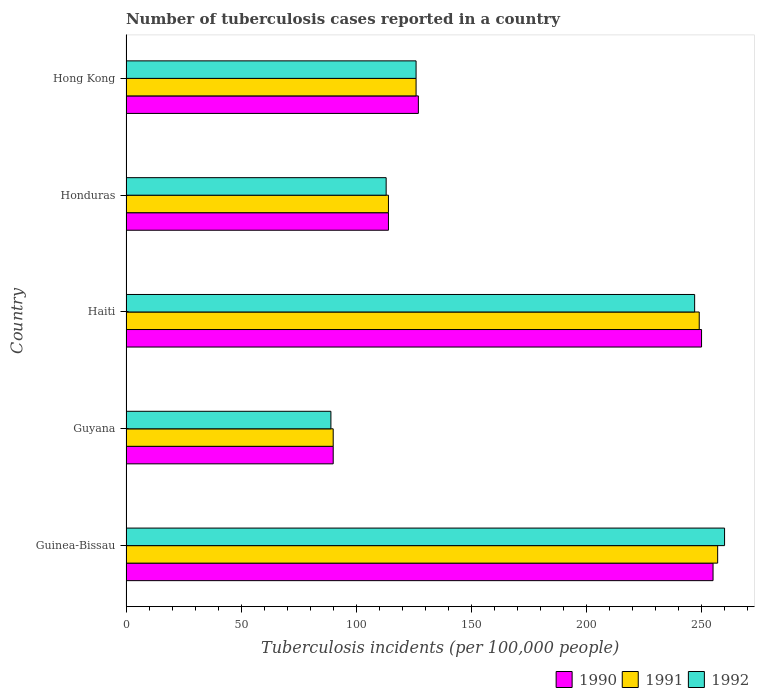How many bars are there on the 3rd tick from the top?
Give a very brief answer. 3. What is the label of the 5th group of bars from the top?
Offer a very short reply. Guinea-Bissau. Across all countries, what is the maximum number of tuberculosis cases reported in in 1992?
Give a very brief answer. 260. Across all countries, what is the minimum number of tuberculosis cases reported in in 1990?
Keep it short and to the point. 90. In which country was the number of tuberculosis cases reported in in 1991 maximum?
Keep it short and to the point. Guinea-Bissau. In which country was the number of tuberculosis cases reported in in 1992 minimum?
Offer a terse response. Guyana. What is the total number of tuberculosis cases reported in in 1991 in the graph?
Provide a short and direct response. 836. What is the difference between the number of tuberculosis cases reported in in 1992 in Guyana and that in Haiti?
Ensure brevity in your answer.  -158. What is the difference between the number of tuberculosis cases reported in in 1990 in Guyana and the number of tuberculosis cases reported in in 1992 in Guinea-Bissau?
Ensure brevity in your answer.  -170. What is the average number of tuberculosis cases reported in in 1992 per country?
Offer a terse response. 167. What is the difference between the number of tuberculosis cases reported in in 1992 and number of tuberculosis cases reported in in 1990 in Guyana?
Your response must be concise. -1. In how many countries, is the number of tuberculosis cases reported in in 1990 greater than 20 ?
Your response must be concise. 5. What is the ratio of the number of tuberculosis cases reported in in 1992 in Guinea-Bissau to that in Haiti?
Offer a very short reply. 1.05. Is the number of tuberculosis cases reported in in 1992 in Haiti less than that in Honduras?
Offer a terse response. No. What is the difference between the highest and the lowest number of tuberculosis cases reported in in 1990?
Provide a short and direct response. 165. In how many countries, is the number of tuberculosis cases reported in in 1992 greater than the average number of tuberculosis cases reported in in 1992 taken over all countries?
Your response must be concise. 2. What does the 2nd bar from the bottom in Haiti represents?
Provide a succinct answer. 1991. What is the difference between two consecutive major ticks on the X-axis?
Make the answer very short. 50. Are the values on the major ticks of X-axis written in scientific E-notation?
Provide a succinct answer. No. Does the graph contain any zero values?
Offer a terse response. No. Where does the legend appear in the graph?
Your response must be concise. Bottom right. What is the title of the graph?
Offer a very short reply. Number of tuberculosis cases reported in a country. What is the label or title of the X-axis?
Your answer should be very brief. Tuberculosis incidents (per 100,0 people). What is the label or title of the Y-axis?
Make the answer very short. Country. What is the Tuberculosis incidents (per 100,000 people) of 1990 in Guinea-Bissau?
Offer a very short reply. 255. What is the Tuberculosis incidents (per 100,000 people) of 1991 in Guinea-Bissau?
Your answer should be very brief. 257. What is the Tuberculosis incidents (per 100,000 people) in 1992 in Guinea-Bissau?
Keep it short and to the point. 260. What is the Tuberculosis incidents (per 100,000 people) in 1990 in Guyana?
Provide a succinct answer. 90. What is the Tuberculosis incidents (per 100,000 people) of 1992 in Guyana?
Your answer should be very brief. 89. What is the Tuberculosis incidents (per 100,000 people) of 1990 in Haiti?
Your answer should be very brief. 250. What is the Tuberculosis incidents (per 100,000 people) of 1991 in Haiti?
Ensure brevity in your answer.  249. What is the Tuberculosis incidents (per 100,000 people) of 1992 in Haiti?
Offer a very short reply. 247. What is the Tuberculosis incidents (per 100,000 people) of 1990 in Honduras?
Offer a very short reply. 114. What is the Tuberculosis incidents (per 100,000 people) in 1991 in Honduras?
Offer a very short reply. 114. What is the Tuberculosis incidents (per 100,000 people) in 1992 in Honduras?
Keep it short and to the point. 113. What is the Tuberculosis incidents (per 100,000 people) of 1990 in Hong Kong?
Your response must be concise. 127. What is the Tuberculosis incidents (per 100,000 people) in 1991 in Hong Kong?
Keep it short and to the point. 126. What is the Tuberculosis incidents (per 100,000 people) of 1992 in Hong Kong?
Offer a terse response. 126. Across all countries, what is the maximum Tuberculosis incidents (per 100,000 people) in 1990?
Provide a short and direct response. 255. Across all countries, what is the maximum Tuberculosis incidents (per 100,000 people) of 1991?
Offer a terse response. 257. Across all countries, what is the maximum Tuberculosis incidents (per 100,000 people) in 1992?
Provide a short and direct response. 260. Across all countries, what is the minimum Tuberculosis incidents (per 100,000 people) in 1992?
Give a very brief answer. 89. What is the total Tuberculosis incidents (per 100,000 people) in 1990 in the graph?
Ensure brevity in your answer.  836. What is the total Tuberculosis incidents (per 100,000 people) of 1991 in the graph?
Make the answer very short. 836. What is the total Tuberculosis incidents (per 100,000 people) in 1992 in the graph?
Your response must be concise. 835. What is the difference between the Tuberculosis incidents (per 100,000 people) of 1990 in Guinea-Bissau and that in Guyana?
Your answer should be very brief. 165. What is the difference between the Tuberculosis incidents (per 100,000 people) in 1991 in Guinea-Bissau and that in Guyana?
Offer a very short reply. 167. What is the difference between the Tuberculosis incidents (per 100,000 people) of 1992 in Guinea-Bissau and that in Guyana?
Ensure brevity in your answer.  171. What is the difference between the Tuberculosis incidents (per 100,000 people) in 1990 in Guinea-Bissau and that in Haiti?
Ensure brevity in your answer.  5. What is the difference between the Tuberculosis incidents (per 100,000 people) of 1992 in Guinea-Bissau and that in Haiti?
Provide a succinct answer. 13. What is the difference between the Tuberculosis incidents (per 100,000 people) of 1990 in Guinea-Bissau and that in Honduras?
Give a very brief answer. 141. What is the difference between the Tuberculosis incidents (per 100,000 people) in 1991 in Guinea-Bissau and that in Honduras?
Ensure brevity in your answer.  143. What is the difference between the Tuberculosis incidents (per 100,000 people) of 1992 in Guinea-Bissau and that in Honduras?
Your response must be concise. 147. What is the difference between the Tuberculosis incidents (per 100,000 people) of 1990 in Guinea-Bissau and that in Hong Kong?
Give a very brief answer. 128. What is the difference between the Tuberculosis incidents (per 100,000 people) of 1991 in Guinea-Bissau and that in Hong Kong?
Your answer should be very brief. 131. What is the difference between the Tuberculosis incidents (per 100,000 people) in 1992 in Guinea-Bissau and that in Hong Kong?
Keep it short and to the point. 134. What is the difference between the Tuberculosis incidents (per 100,000 people) of 1990 in Guyana and that in Haiti?
Offer a terse response. -160. What is the difference between the Tuberculosis incidents (per 100,000 people) in 1991 in Guyana and that in Haiti?
Provide a short and direct response. -159. What is the difference between the Tuberculosis incidents (per 100,000 people) in 1992 in Guyana and that in Haiti?
Provide a short and direct response. -158. What is the difference between the Tuberculosis incidents (per 100,000 people) of 1991 in Guyana and that in Honduras?
Your answer should be compact. -24. What is the difference between the Tuberculosis incidents (per 100,000 people) in 1992 in Guyana and that in Honduras?
Provide a succinct answer. -24. What is the difference between the Tuberculosis incidents (per 100,000 people) in 1990 in Guyana and that in Hong Kong?
Your answer should be compact. -37. What is the difference between the Tuberculosis incidents (per 100,000 people) of 1991 in Guyana and that in Hong Kong?
Offer a very short reply. -36. What is the difference between the Tuberculosis incidents (per 100,000 people) in 1992 in Guyana and that in Hong Kong?
Your response must be concise. -37. What is the difference between the Tuberculosis incidents (per 100,000 people) in 1990 in Haiti and that in Honduras?
Your answer should be compact. 136. What is the difference between the Tuberculosis incidents (per 100,000 people) in 1991 in Haiti and that in Honduras?
Offer a terse response. 135. What is the difference between the Tuberculosis incidents (per 100,000 people) of 1992 in Haiti and that in Honduras?
Your response must be concise. 134. What is the difference between the Tuberculosis incidents (per 100,000 people) in 1990 in Haiti and that in Hong Kong?
Provide a short and direct response. 123. What is the difference between the Tuberculosis incidents (per 100,000 people) of 1991 in Haiti and that in Hong Kong?
Your response must be concise. 123. What is the difference between the Tuberculosis incidents (per 100,000 people) of 1992 in Haiti and that in Hong Kong?
Your response must be concise. 121. What is the difference between the Tuberculosis incidents (per 100,000 people) in 1991 in Honduras and that in Hong Kong?
Provide a succinct answer. -12. What is the difference between the Tuberculosis incidents (per 100,000 people) of 1990 in Guinea-Bissau and the Tuberculosis incidents (per 100,000 people) of 1991 in Guyana?
Your response must be concise. 165. What is the difference between the Tuberculosis incidents (per 100,000 people) in 1990 in Guinea-Bissau and the Tuberculosis incidents (per 100,000 people) in 1992 in Guyana?
Offer a terse response. 166. What is the difference between the Tuberculosis incidents (per 100,000 people) in 1991 in Guinea-Bissau and the Tuberculosis incidents (per 100,000 people) in 1992 in Guyana?
Give a very brief answer. 168. What is the difference between the Tuberculosis incidents (per 100,000 people) of 1990 in Guinea-Bissau and the Tuberculosis incidents (per 100,000 people) of 1991 in Haiti?
Your answer should be compact. 6. What is the difference between the Tuberculosis incidents (per 100,000 people) of 1990 in Guinea-Bissau and the Tuberculosis incidents (per 100,000 people) of 1991 in Honduras?
Give a very brief answer. 141. What is the difference between the Tuberculosis incidents (per 100,000 people) in 1990 in Guinea-Bissau and the Tuberculosis incidents (per 100,000 people) in 1992 in Honduras?
Your response must be concise. 142. What is the difference between the Tuberculosis incidents (per 100,000 people) of 1991 in Guinea-Bissau and the Tuberculosis incidents (per 100,000 people) of 1992 in Honduras?
Your response must be concise. 144. What is the difference between the Tuberculosis incidents (per 100,000 people) in 1990 in Guinea-Bissau and the Tuberculosis incidents (per 100,000 people) in 1991 in Hong Kong?
Your answer should be compact. 129. What is the difference between the Tuberculosis incidents (per 100,000 people) in 1990 in Guinea-Bissau and the Tuberculosis incidents (per 100,000 people) in 1992 in Hong Kong?
Your response must be concise. 129. What is the difference between the Tuberculosis incidents (per 100,000 people) in 1991 in Guinea-Bissau and the Tuberculosis incidents (per 100,000 people) in 1992 in Hong Kong?
Offer a terse response. 131. What is the difference between the Tuberculosis incidents (per 100,000 people) in 1990 in Guyana and the Tuberculosis incidents (per 100,000 people) in 1991 in Haiti?
Make the answer very short. -159. What is the difference between the Tuberculosis incidents (per 100,000 people) in 1990 in Guyana and the Tuberculosis incidents (per 100,000 people) in 1992 in Haiti?
Keep it short and to the point. -157. What is the difference between the Tuberculosis incidents (per 100,000 people) in 1991 in Guyana and the Tuberculosis incidents (per 100,000 people) in 1992 in Haiti?
Offer a terse response. -157. What is the difference between the Tuberculosis incidents (per 100,000 people) of 1990 in Guyana and the Tuberculosis incidents (per 100,000 people) of 1991 in Honduras?
Your response must be concise. -24. What is the difference between the Tuberculosis incidents (per 100,000 people) of 1990 in Guyana and the Tuberculosis incidents (per 100,000 people) of 1991 in Hong Kong?
Your response must be concise. -36. What is the difference between the Tuberculosis incidents (per 100,000 people) of 1990 in Guyana and the Tuberculosis incidents (per 100,000 people) of 1992 in Hong Kong?
Make the answer very short. -36. What is the difference between the Tuberculosis incidents (per 100,000 people) in 1991 in Guyana and the Tuberculosis incidents (per 100,000 people) in 1992 in Hong Kong?
Provide a succinct answer. -36. What is the difference between the Tuberculosis incidents (per 100,000 people) of 1990 in Haiti and the Tuberculosis incidents (per 100,000 people) of 1991 in Honduras?
Your answer should be very brief. 136. What is the difference between the Tuberculosis incidents (per 100,000 people) of 1990 in Haiti and the Tuberculosis incidents (per 100,000 people) of 1992 in Honduras?
Make the answer very short. 137. What is the difference between the Tuberculosis incidents (per 100,000 people) in 1991 in Haiti and the Tuberculosis incidents (per 100,000 people) in 1992 in Honduras?
Make the answer very short. 136. What is the difference between the Tuberculosis incidents (per 100,000 people) in 1990 in Haiti and the Tuberculosis incidents (per 100,000 people) in 1991 in Hong Kong?
Offer a terse response. 124. What is the difference between the Tuberculosis incidents (per 100,000 people) of 1990 in Haiti and the Tuberculosis incidents (per 100,000 people) of 1992 in Hong Kong?
Your answer should be very brief. 124. What is the difference between the Tuberculosis incidents (per 100,000 people) of 1991 in Haiti and the Tuberculosis incidents (per 100,000 people) of 1992 in Hong Kong?
Keep it short and to the point. 123. What is the difference between the Tuberculosis incidents (per 100,000 people) of 1990 in Honduras and the Tuberculosis incidents (per 100,000 people) of 1992 in Hong Kong?
Your response must be concise. -12. What is the average Tuberculosis incidents (per 100,000 people) in 1990 per country?
Make the answer very short. 167.2. What is the average Tuberculosis incidents (per 100,000 people) in 1991 per country?
Provide a short and direct response. 167.2. What is the average Tuberculosis incidents (per 100,000 people) of 1992 per country?
Your response must be concise. 167. What is the difference between the Tuberculosis incidents (per 100,000 people) of 1990 and Tuberculosis incidents (per 100,000 people) of 1991 in Guinea-Bissau?
Keep it short and to the point. -2. What is the difference between the Tuberculosis incidents (per 100,000 people) of 1990 and Tuberculosis incidents (per 100,000 people) of 1992 in Guinea-Bissau?
Keep it short and to the point. -5. What is the difference between the Tuberculosis incidents (per 100,000 people) of 1991 and Tuberculosis incidents (per 100,000 people) of 1992 in Guinea-Bissau?
Your answer should be compact. -3. What is the difference between the Tuberculosis incidents (per 100,000 people) in 1990 and Tuberculosis incidents (per 100,000 people) in 1992 in Haiti?
Ensure brevity in your answer.  3. What is the difference between the Tuberculosis incidents (per 100,000 people) of 1991 and Tuberculosis incidents (per 100,000 people) of 1992 in Haiti?
Offer a terse response. 2. What is the difference between the Tuberculosis incidents (per 100,000 people) of 1990 and Tuberculosis incidents (per 100,000 people) of 1991 in Honduras?
Your answer should be compact. 0. What is the ratio of the Tuberculosis incidents (per 100,000 people) of 1990 in Guinea-Bissau to that in Guyana?
Ensure brevity in your answer.  2.83. What is the ratio of the Tuberculosis incidents (per 100,000 people) in 1991 in Guinea-Bissau to that in Guyana?
Offer a very short reply. 2.86. What is the ratio of the Tuberculosis incidents (per 100,000 people) in 1992 in Guinea-Bissau to that in Guyana?
Make the answer very short. 2.92. What is the ratio of the Tuberculosis incidents (per 100,000 people) in 1991 in Guinea-Bissau to that in Haiti?
Give a very brief answer. 1.03. What is the ratio of the Tuberculosis incidents (per 100,000 people) of 1992 in Guinea-Bissau to that in Haiti?
Ensure brevity in your answer.  1.05. What is the ratio of the Tuberculosis incidents (per 100,000 people) in 1990 in Guinea-Bissau to that in Honduras?
Give a very brief answer. 2.24. What is the ratio of the Tuberculosis incidents (per 100,000 people) in 1991 in Guinea-Bissau to that in Honduras?
Ensure brevity in your answer.  2.25. What is the ratio of the Tuberculosis incidents (per 100,000 people) in 1992 in Guinea-Bissau to that in Honduras?
Your answer should be compact. 2.3. What is the ratio of the Tuberculosis incidents (per 100,000 people) of 1990 in Guinea-Bissau to that in Hong Kong?
Your answer should be very brief. 2.01. What is the ratio of the Tuberculosis incidents (per 100,000 people) of 1991 in Guinea-Bissau to that in Hong Kong?
Offer a terse response. 2.04. What is the ratio of the Tuberculosis incidents (per 100,000 people) in 1992 in Guinea-Bissau to that in Hong Kong?
Make the answer very short. 2.06. What is the ratio of the Tuberculosis incidents (per 100,000 people) in 1990 in Guyana to that in Haiti?
Offer a very short reply. 0.36. What is the ratio of the Tuberculosis incidents (per 100,000 people) of 1991 in Guyana to that in Haiti?
Make the answer very short. 0.36. What is the ratio of the Tuberculosis incidents (per 100,000 people) of 1992 in Guyana to that in Haiti?
Your answer should be compact. 0.36. What is the ratio of the Tuberculosis incidents (per 100,000 people) of 1990 in Guyana to that in Honduras?
Provide a short and direct response. 0.79. What is the ratio of the Tuberculosis incidents (per 100,000 people) in 1991 in Guyana to that in Honduras?
Give a very brief answer. 0.79. What is the ratio of the Tuberculosis incidents (per 100,000 people) in 1992 in Guyana to that in Honduras?
Provide a succinct answer. 0.79. What is the ratio of the Tuberculosis incidents (per 100,000 people) of 1990 in Guyana to that in Hong Kong?
Make the answer very short. 0.71. What is the ratio of the Tuberculosis incidents (per 100,000 people) of 1992 in Guyana to that in Hong Kong?
Provide a succinct answer. 0.71. What is the ratio of the Tuberculosis incidents (per 100,000 people) in 1990 in Haiti to that in Honduras?
Make the answer very short. 2.19. What is the ratio of the Tuberculosis incidents (per 100,000 people) of 1991 in Haiti to that in Honduras?
Keep it short and to the point. 2.18. What is the ratio of the Tuberculosis incidents (per 100,000 people) in 1992 in Haiti to that in Honduras?
Your response must be concise. 2.19. What is the ratio of the Tuberculosis incidents (per 100,000 people) in 1990 in Haiti to that in Hong Kong?
Offer a terse response. 1.97. What is the ratio of the Tuberculosis incidents (per 100,000 people) of 1991 in Haiti to that in Hong Kong?
Your answer should be compact. 1.98. What is the ratio of the Tuberculosis incidents (per 100,000 people) of 1992 in Haiti to that in Hong Kong?
Keep it short and to the point. 1.96. What is the ratio of the Tuberculosis incidents (per 100,000 people) of 1990 in Honduras to that in Hong Kong?
Offer a very short reply. 0.9. What is the ratio of the Tuberculosis incidents (per 100,000 people) in 1991 in Honduras to that in Hong Kong?
Keep it short and to the point. 0.9. What is the ratio of the Tuberculosis incidents (per 100,000 people) of 1992 in Honduras to that in Hong Kong?
Make the answer very short. 0.9. What is the difference between the highest and the second highest Tuberculosis incidents (per 100,000 people) of 1990?
Your answer should be compact. 5. What is the difference between the highest and the second highest Tuberculosis incidents (per 100,000 people) in 1991?
Give a very brief answer. 8. What is the difference between the highest and the lowest Tuberculosis incidents (per 100,000 people) in 1990?
Provide a succinct answer. 165. What is the difference between the highest and the lowest Tuberculosis incidents (per 100,000 people) in 1991?
Provide a short and direct response. 167. What is the difference between the highest and the lowest Tuberculosis incidents (per 100,000 people) in 1992?
Ensure brevity in your answer.  171. 